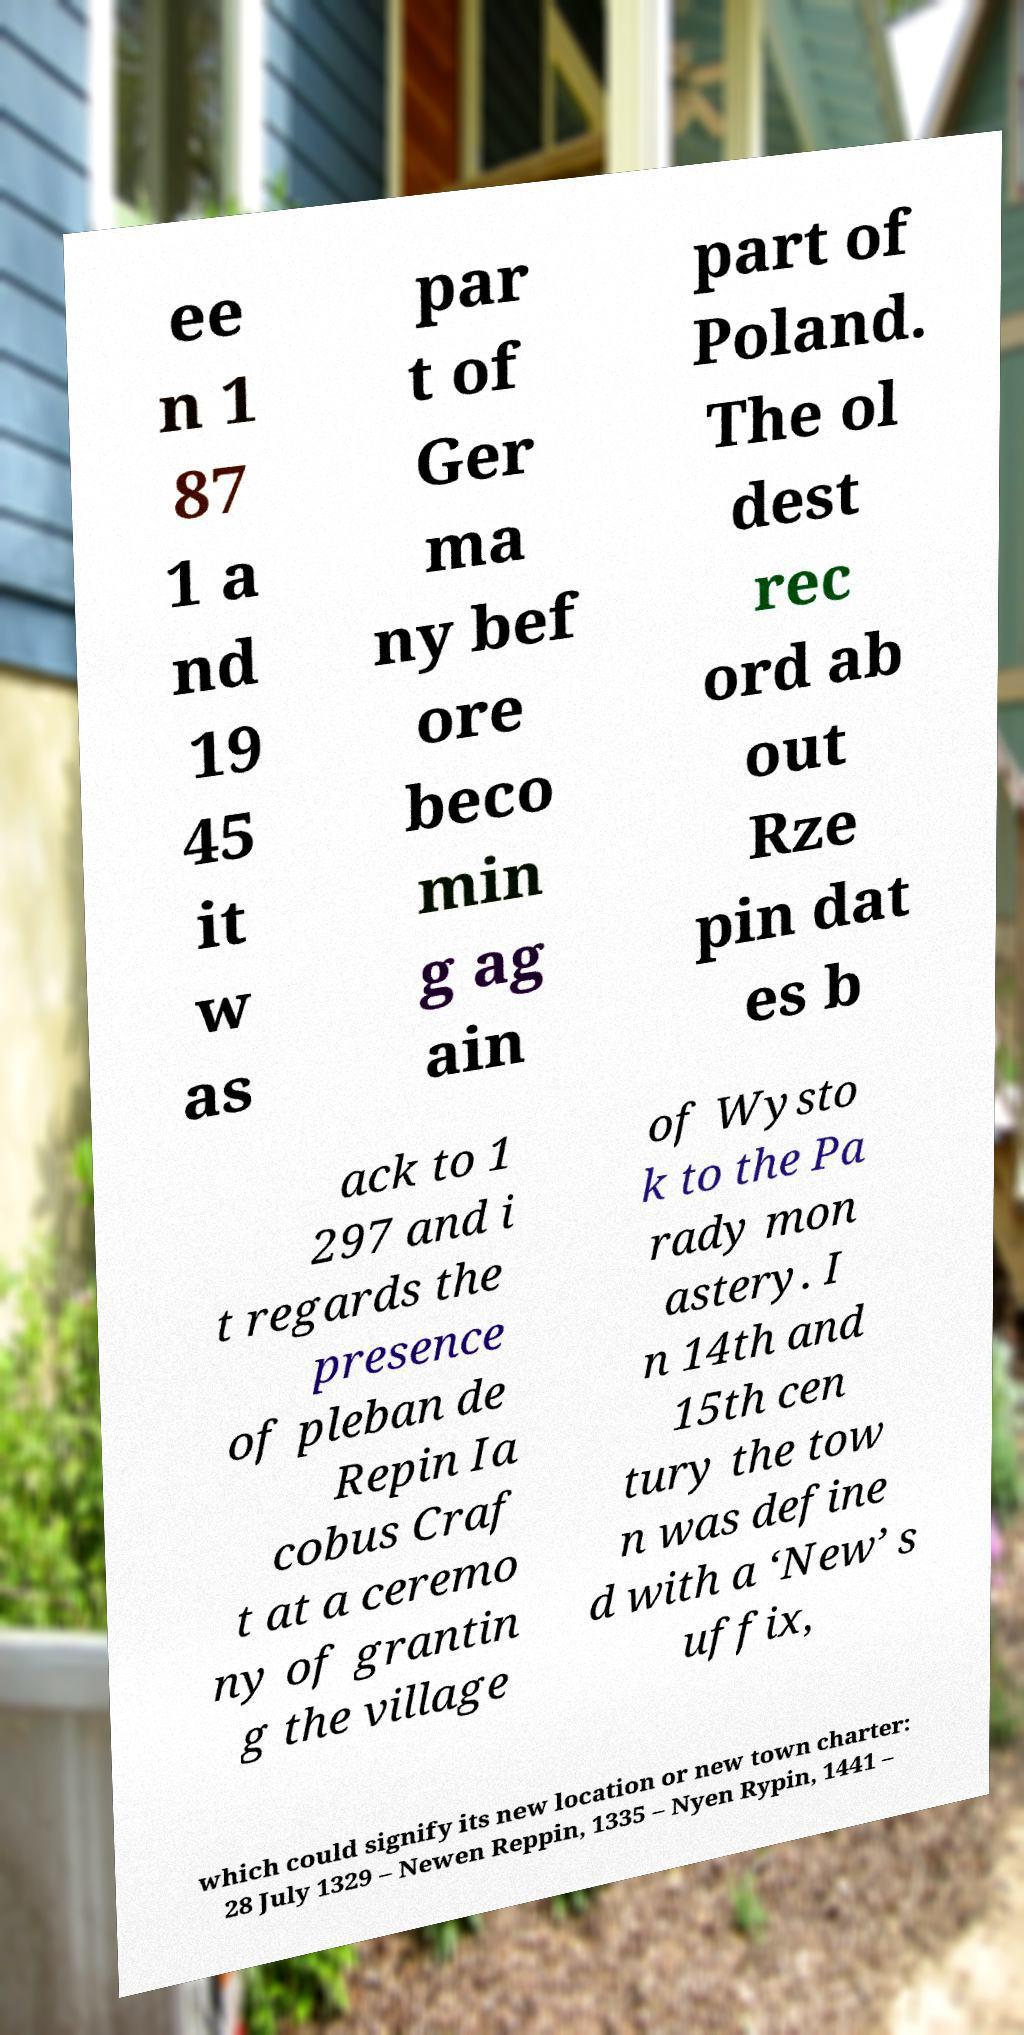Could you assist in decoding the text presented in this image and type it out clearly? ee n 1 87 1 a nd 19 45 it w as par t of Ger ma ny bef ore beco min g ag ain part of Poland. The ol dest rec ord ab out Rze pin dat es b ack to 1 297 and i t regards the presence of pleban de Repin Ia cobus Craf t at a ceremo ny of grantin g the village of Wysto k to the Pa rady mon astery. I n 14th and 15th cen tury the tow n was define d with a ‘New’ s uffix, which could signify its new location or new town charter: 28 July 1329 – Newen Reppin, 1335 – Nyen Rypin, 1441 – 